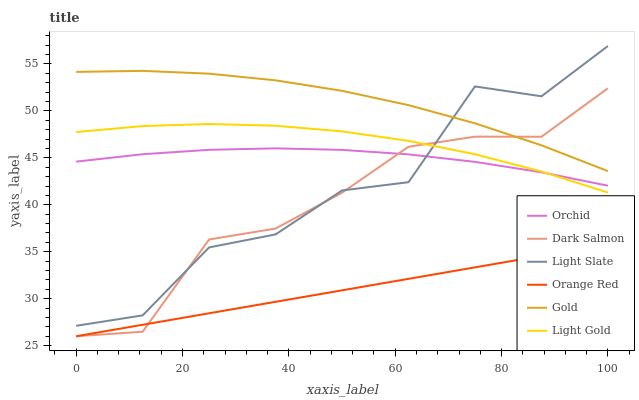Does Light Slate have the minimum area under the curve?
Answer yes or no. No. Does Light Slate have the maximum area under the curve?
Answer yes or no. No. Is Dark Salmon the smoothest?
Answer yes or no. No. Is Dark Salmon the roughest?
Answer yes or no. No. Does Light Slate have the lowest value?
Answer yes or no. No. Does Dark Salmon have the highest value?
Answer yes or no. No. Is Orange Red less than Light Slate?
Answer yes or no. Yes. Is Light Gold greater than Orange Red?
Answer yes or no. Yes. Does Orange Red intersect Light Slate?
Answer yes or no. No. 